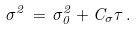<formula> <loc_0><loc_0><loc_500><loc_500>\sigma ^ { 2 } \, = \, \sigma _ { 0 } ^ { 2 } + C _ { \sigma } \tau \, .</formula> 